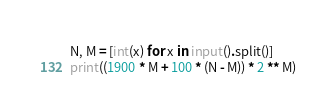Convert code to text. <code><loc_0><loc_0><loc_500><loc_500><_Python_>N, M = [int(x) for x in input().split()]
print((1900 * M + 100 * (N - M)) * 2 ** M)</code> 